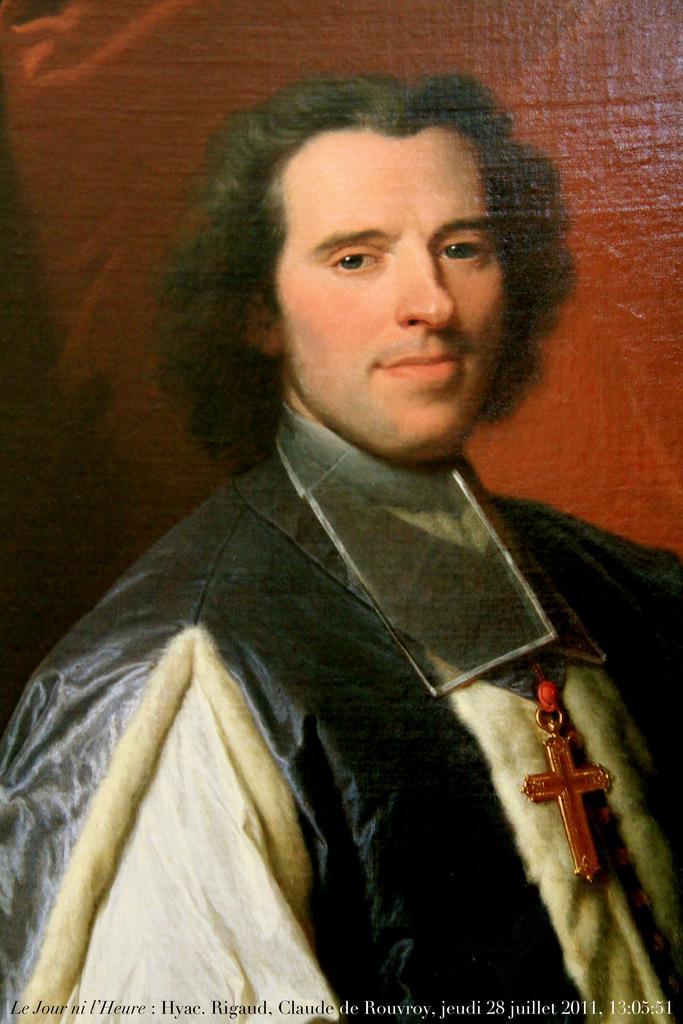Can you describe this image briefly? In this image I see a painting of a man and I see that he is wearing black and white dress and it is red in the background and I see the watermark over here. 